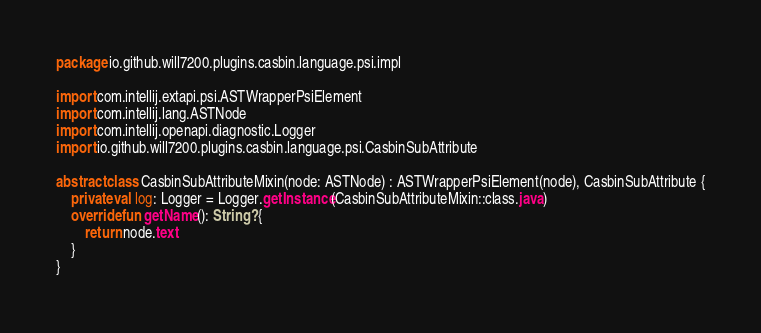Convert code to text. <code><loc_0><loc_0><loc_500><loc_500><_Kotlin_>package io.github.will7200.plugins.casbin.language.psi.impl

import com.intellij.extapi.psi.ASTWrapperPsiElement
import com.intellij.lang.ASTNode
import com.intellij.openapi.diagnostic.Logger
import io.github.will7200.plugins.casbin.language.psi.CasbinSubAttribute

abstract class CasbinSubAttributeMixin(node: ASTNode) : ASTWrapperPsiElement(node), CasbinSubAttribute {
    private val log: Logger = Logger.getInstance(CasbinSubAttributeMixin::class.java)
    override fun getName(): String? {
        return node.text
    }
}</code> 